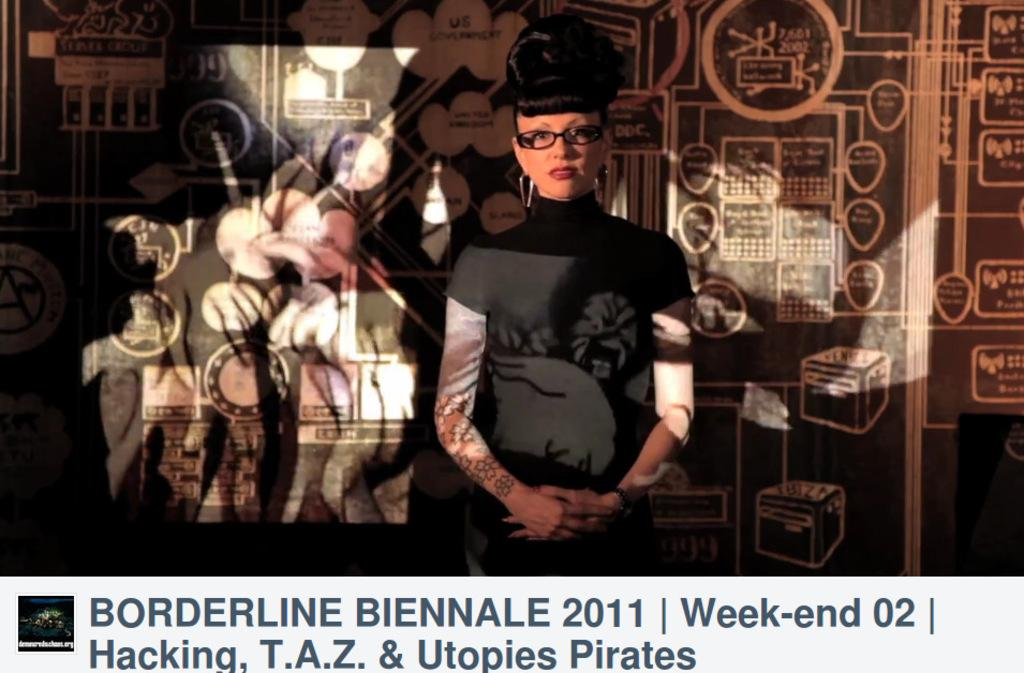Who is present in the image? There is a woman in the image. What can be seen on the wall in the image? There is a wall with paintings in the image, and there is also text on the wall. Can you describe the text in the image? There is text at the bottom of the image as well as on the wall. What type of juice is being poured out of the box in the image? There is no juice or box present in the image. 